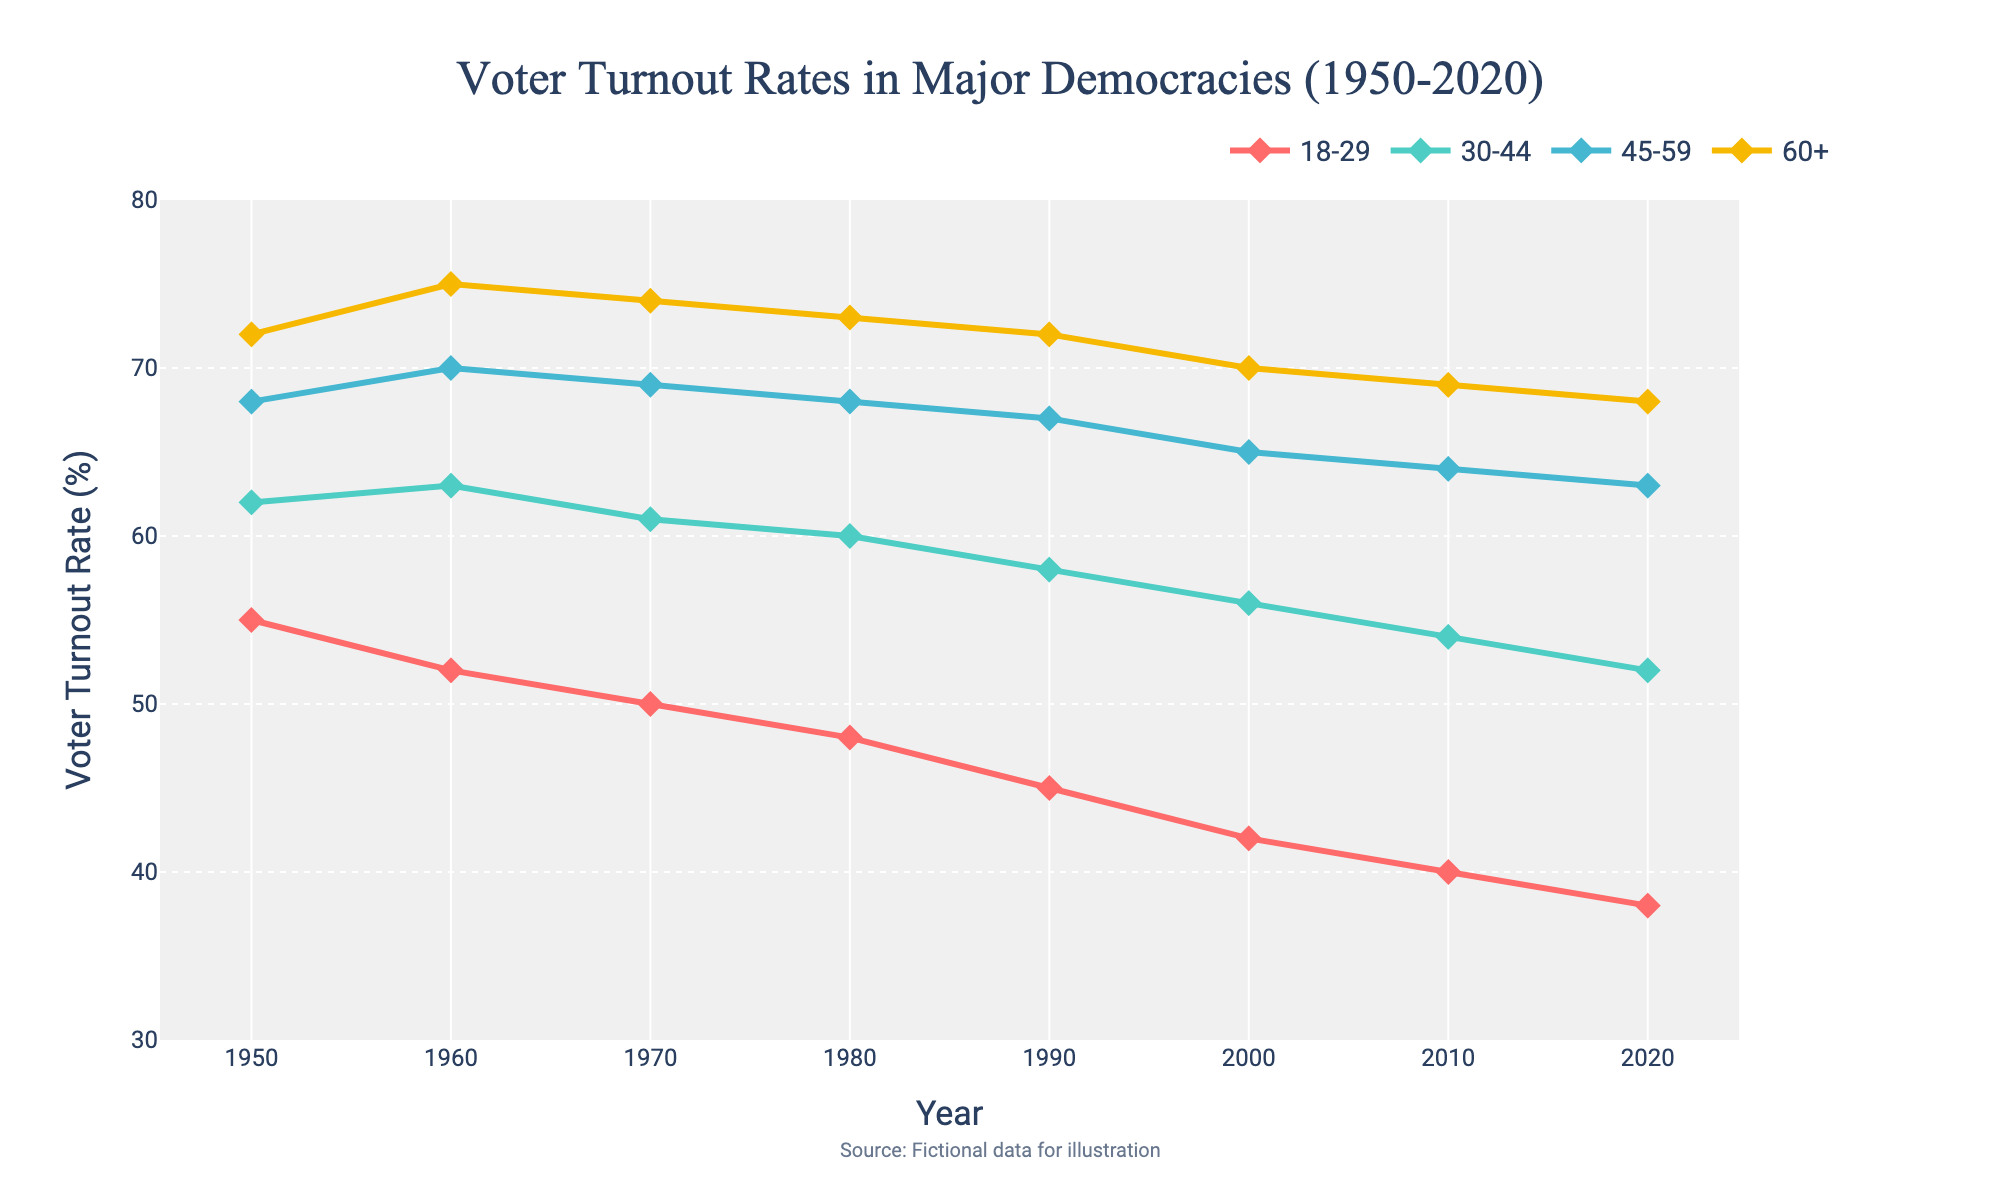What is the voter turnout rate for the age group 18-29 in 2020? Refer to the marker position for the year 2020 on the line representing the 18-29 age group. The value indicated is 38%.
Answer: 38% Which age group had the highest voter turnout rate in 1950? Examine the line markers at the year 1950 for all age groups. The 60+ age group has the highest marker at 72%.
Answer: The 60+ age group How did the voter turnout rate for the age group 30-44 change from 1950 to 2020? Identify the markers for the 30-44 age group at 1950 and 2020. The values are 62% in 1950 and 52% in 2020, showing a decrease of 10 percentage points.
Answer: Decreased by 10 percentage points Which age group had the smallest decrease in voter turnout rate from 1950 to 2020? Compare the differences between the markers for each age group in 1950 and 2020. The 45-59 age group decreases from 68% to 63%, which is a 5 percentage points drop. This is the smallest decrease among the age groups.
Answer: The 45-59 age group By how many percentage points did the turnout rate for the 60+ age group decrease from 1980 to 2020? Identify the markers for the 60+ age group in 1980 and 2020. In 1980 it was 73%, and in 2020 it was 68%. The decrease is 73% - 68% = 5 percentage points.
Answer: 5 percentage points Between which decades did the age group 18-29 witness the largest drop in voter turnout rate? Examine the changes in voter turnout rates of the 18-29 age group between each decade: 
- 1950 to 1960: 55% to 52% (3 points)
- 1960 to 1970: 52% to 50% (2 points)
- 1970 to 1980: 50% to 48% (2 points)
- 1980 to 1990: 48% to 45% (3 points)
- 1990 to 2000: 45% to 42% (3 points)
- 2000 to 2010: 42% to 40% (2 points)
- 2010 to 2020: 40% to 38% (2 points)
The drop between 1950 to 1960, 1980 to 1990 and 1990 to 2000 are each 3 points, the largest observed among the intervals.
Answer: 1950 to 1960, 1980 to 1990, and 1990 to 2000 What's the average voter turnout rate for the age group 45-59 over the years shown? Sum the turnout rates for the age group 45-59 across all years and divide by the number of years: (68 + 70 + 69 + 68 + 67 + 65 + 64 + 63) / 8 = 66.75.
Answer: 66.75% Which age group’s voter turnout rate has shown a more consistent downward trend since 1950? Identify lines that show a consistent decrease without fluctuations. The 18-29 age group shows a steady decline from 55% in 1950 to 38% in 2020 without any increases.
Answer: The 18-29 age group 